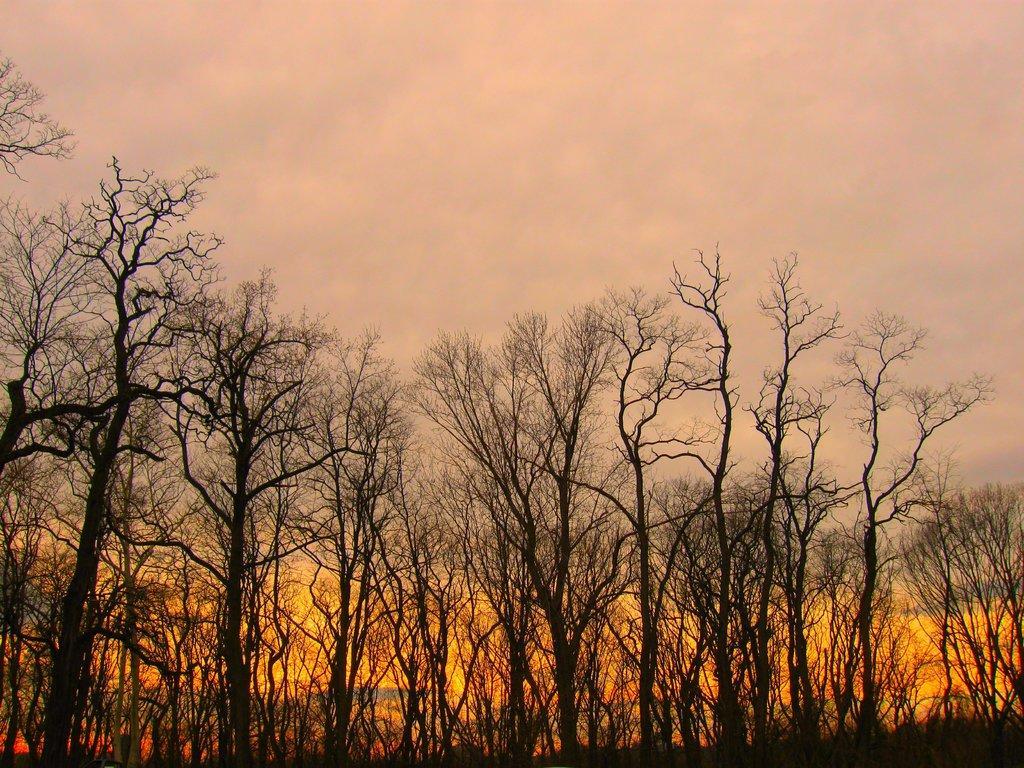Please provide a concise description of this image. In the picture I can see so many trees and clouded sky. 